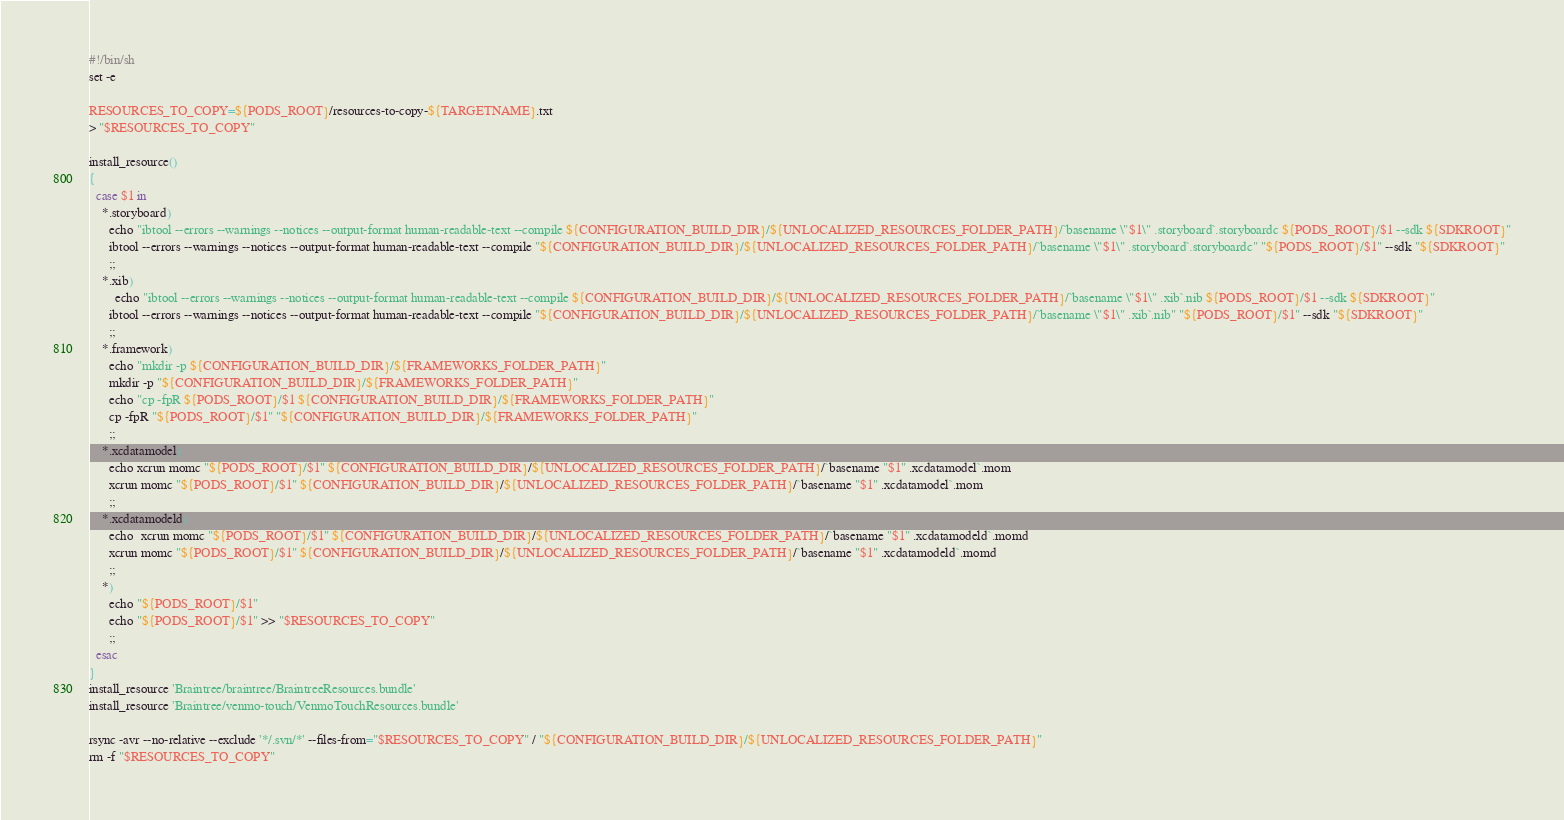Convert code to text. <code><loc_0><loc_0><loc_500><loc_500><_Bash_>#!/bin/sh
set -e

RESOURCES_TO_COPY=${PODS_ROOT}/resources-to-copy-${TARGETNAME}.txt
> "$RESOURCES_TO_COPY"

install_resource()
{
  case $1 in
    *.storyboard)
      echo "ibtool --errors --warnings --notices --output-format human-readable-text --compile ${CONFIGURATION_BUILD_DIR}/${UNLOCALIZED_RESOURCES_FOLDER_PATH}/`basename \"$1\" .storyboard`.storyboardc ${PODS_ROOT}/$1 --sdk ${SDKROOT}"
      ibtool --errors --warnings --notices --output-format human-readable-text --compile "${CONFIGURATION_BUILD_DIR}/${UNLOCALIZED_RESOURCES_FOLDER_PATH}/`basename \"$1\" .storyboard`.storyboardc" "${PODS_ROOT}/$1" --sdk "${SDKROOT}"
      ;;
    *.xib)
        echo "ibtool --errors --warnings --notices --output-format human-readable-text --compile ${CONFIGURATION_BUILD_DIR}/${UNLOCALIZED_RESOURCES_FOLDER_PATH}/`basename \"$1\" .xib`.nib ${PODS_ROOT}/$1 --sdk ${SDKROOT}"
      ibtool --errors --warnings --notices --output-format human-readable-text --compile "${CONFIGURATION_BUILD_DIR}/${UNLOCALIZED_RESOURCES_FOLDER_PATH}/`basename \"$1\" .xib`.nib" "${PODS_ROOT}/$1" --sdk "${SDKROOT}"
      ;;
    *.framework)
      echo "mkdir -p ${CONFIGURATION_BUILD_DIR}/${FRAMEWORKS_FOLDER_PATH}"
      mkdir -p "${CONFIGURATION_BUILD_DIR}/${FRAMEWORKS_FOLDER_PATH}"
      echo "cp -fpR ${PODS_ROOT}/$1 ${CONFIGURATION_BUILD_DIR}/${FRAMEWORKS_FOLDER_PATH}"
      cp -fpR "${PODS_ROOT}/$1" "${CONFIGURATION_BUILD_DIR}/${FRAMEWORKS_FOLDER_PATH}"
      ;;
    *.xcdatamodel)
      echo xcrun momc "${PODS_ROOT}/$1" ${CONFIGURATION_BUILD_DIR}/${UNLOCALIZED_RESOURCES_FOLDER_PATH}/`basename "$1" .xcdatamodel`.mom
      xcrun momc "${PODS_ROOT}/$1" ${CONFIGURATION_BUILD_DIR}/${UNLOCALIZED_RESOURCES_FOLDER_PATH}/`basename "$1" .xcdatamodel`.mom
      ;;
    *.xcdatamodeld)
      echo  xcrun momc "${PODS_ROOT}/$1" ${CONFIGURATION_BUILD_DIR}/${UNLOCALIZED_RESOURCES_FOLDER_PATH}/`basename "$1" .xcdatamodeld`.momd
      xcrun momc "${PODS_ROOT}/$1" ${CONFIGURATION_BUILD_DIR}/${UNLOCALIZED_RESOURCES_FOLDER_PATH}/`basename "$1" .xcdatamodeld`.momd
      ;;
    *)
      echo "${PODS_ROOT}/$1"
      echo "${PODS_ROOT}/$1" >> "$RESOURCES_TO_COPY"
      ;;
  esac
}
install_resource 'Braintree/braintree/BraintreeResources.bundle'
install_resource 'Braintree/venmo-touch/VenmoTouchResources.bundle'

rsync -avr --no-relative --exclude '*/.svn/*' --files-from="$RESOURCES_TO_COPY" / "${CONFIGURATION_BUILD_DIR}/${UNLOCALIZED_RESOURCES_FOLDER_PATH}"
rm -f "$RESOURCES_TO_COPY"
</code> 